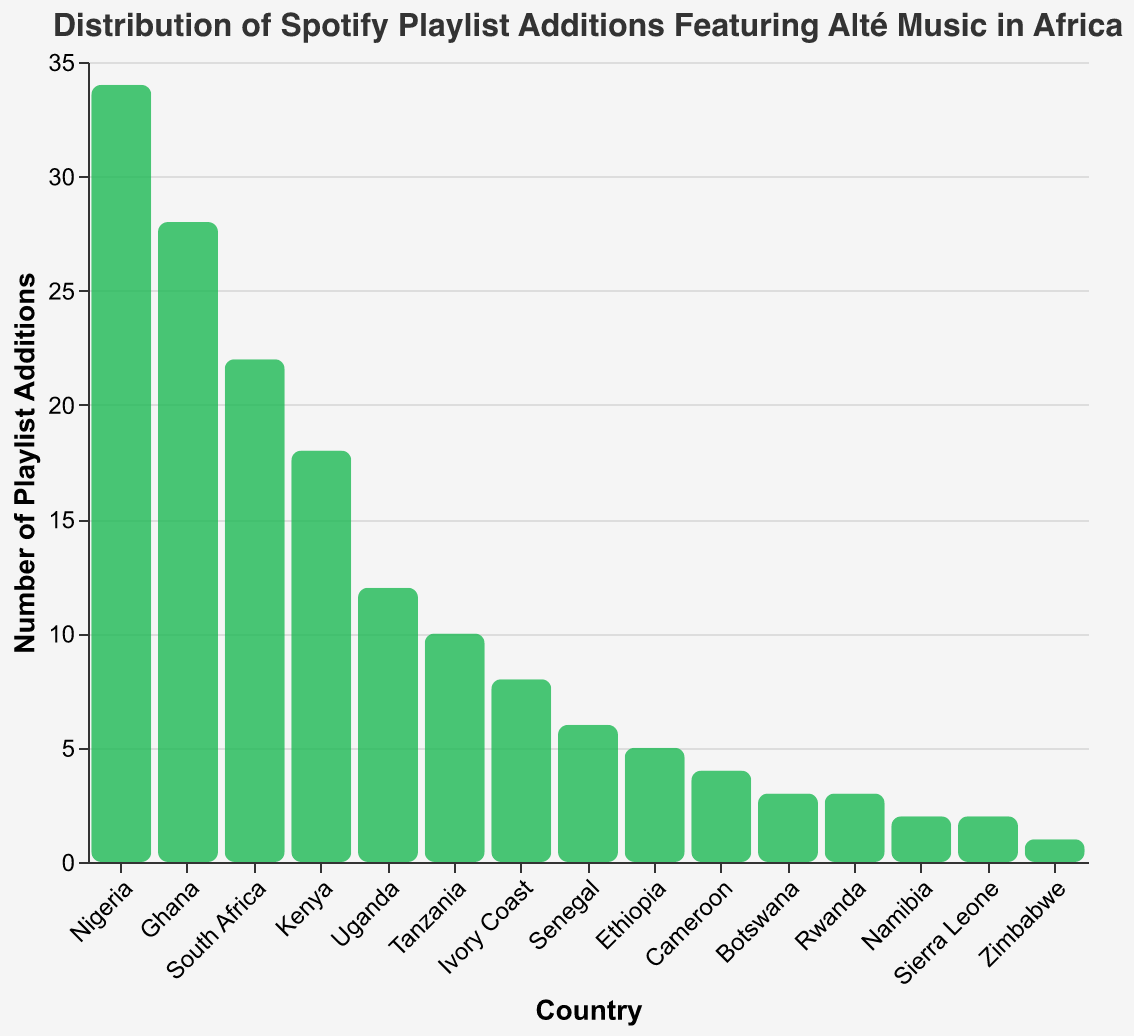What's the title of the figure? The title is usually displayed at the top of the figure. Here, it reads "Distribution of Spotify Playlist Additions Featuring Alté Music in Africa".
Answer: Distribution of Spotify Playlist Additions Featuring Alté Music in Africa Which country has the highest number of Spotify playlist additions featuring alté music? From the figure, the tallest bar represents the country with the highest number of playlist additions. Nigeria has the tallest bar.
Answer: Nigeria How many Spotify playlist additions does Ghana have? Locate the bar corresponding to Ghana on the x-axis and read its height on the y-axis. The height indicates Ghana has 28 playlist additions.
Answer: 28 Which countries have fewer than 5 playlist additions? Identify bars with heights less than the 5 mark on the y-axis. These countries are Ethiopia, Cameroon, Botswana, Rwanda, Namibia, Sierra Leone, and Zimbabwe.
Answer: Ethiopia, Cameroon, Botswana, Rwanda, Namibia, Sierra Leone, Zimbabwe What's the total number of playlist additions for Kenya and South Africa combined? Sum the heights of the bars for Kenya (18) and South Africa (22). The total is 18 + 22.
Answer: 40 How do Uganda and Tanzania compare in terms of playlist additions? Compare the heights of the bars for Uganda and Tanzania. Uganda has 12 playlist additions, while Tanzania has 10. Uganda has more.
Answer: Uganda has more What is the average number of playlist additions for the top three countries? Add the playlist additions for the top three countries, Nigeria (34), Ghana (28), and South Africa (22). Then, divide by 3: (34 + 28 + 22) / 3 = 84 / 3.
Answer: 28 Which country has the least number of Spotify playlist additions? The shortest bar represents the country with the least additions. Zimbabwe has the shortest bar.
Answer: Zimbabwe What is the difference in playlist additions between Ghana and Uganda? Subtract Uganda's playlist additions from Ghana's. Ghana has 28, and Uganda has 12. The difference is 28 - 12.
Answer: 16 How many countries have more than 20 playlist additions? Count the bars with heights greater than 20. These countries are Nigeria, Ghana, and South Africa. There are 3 countries.
Answer: 3 